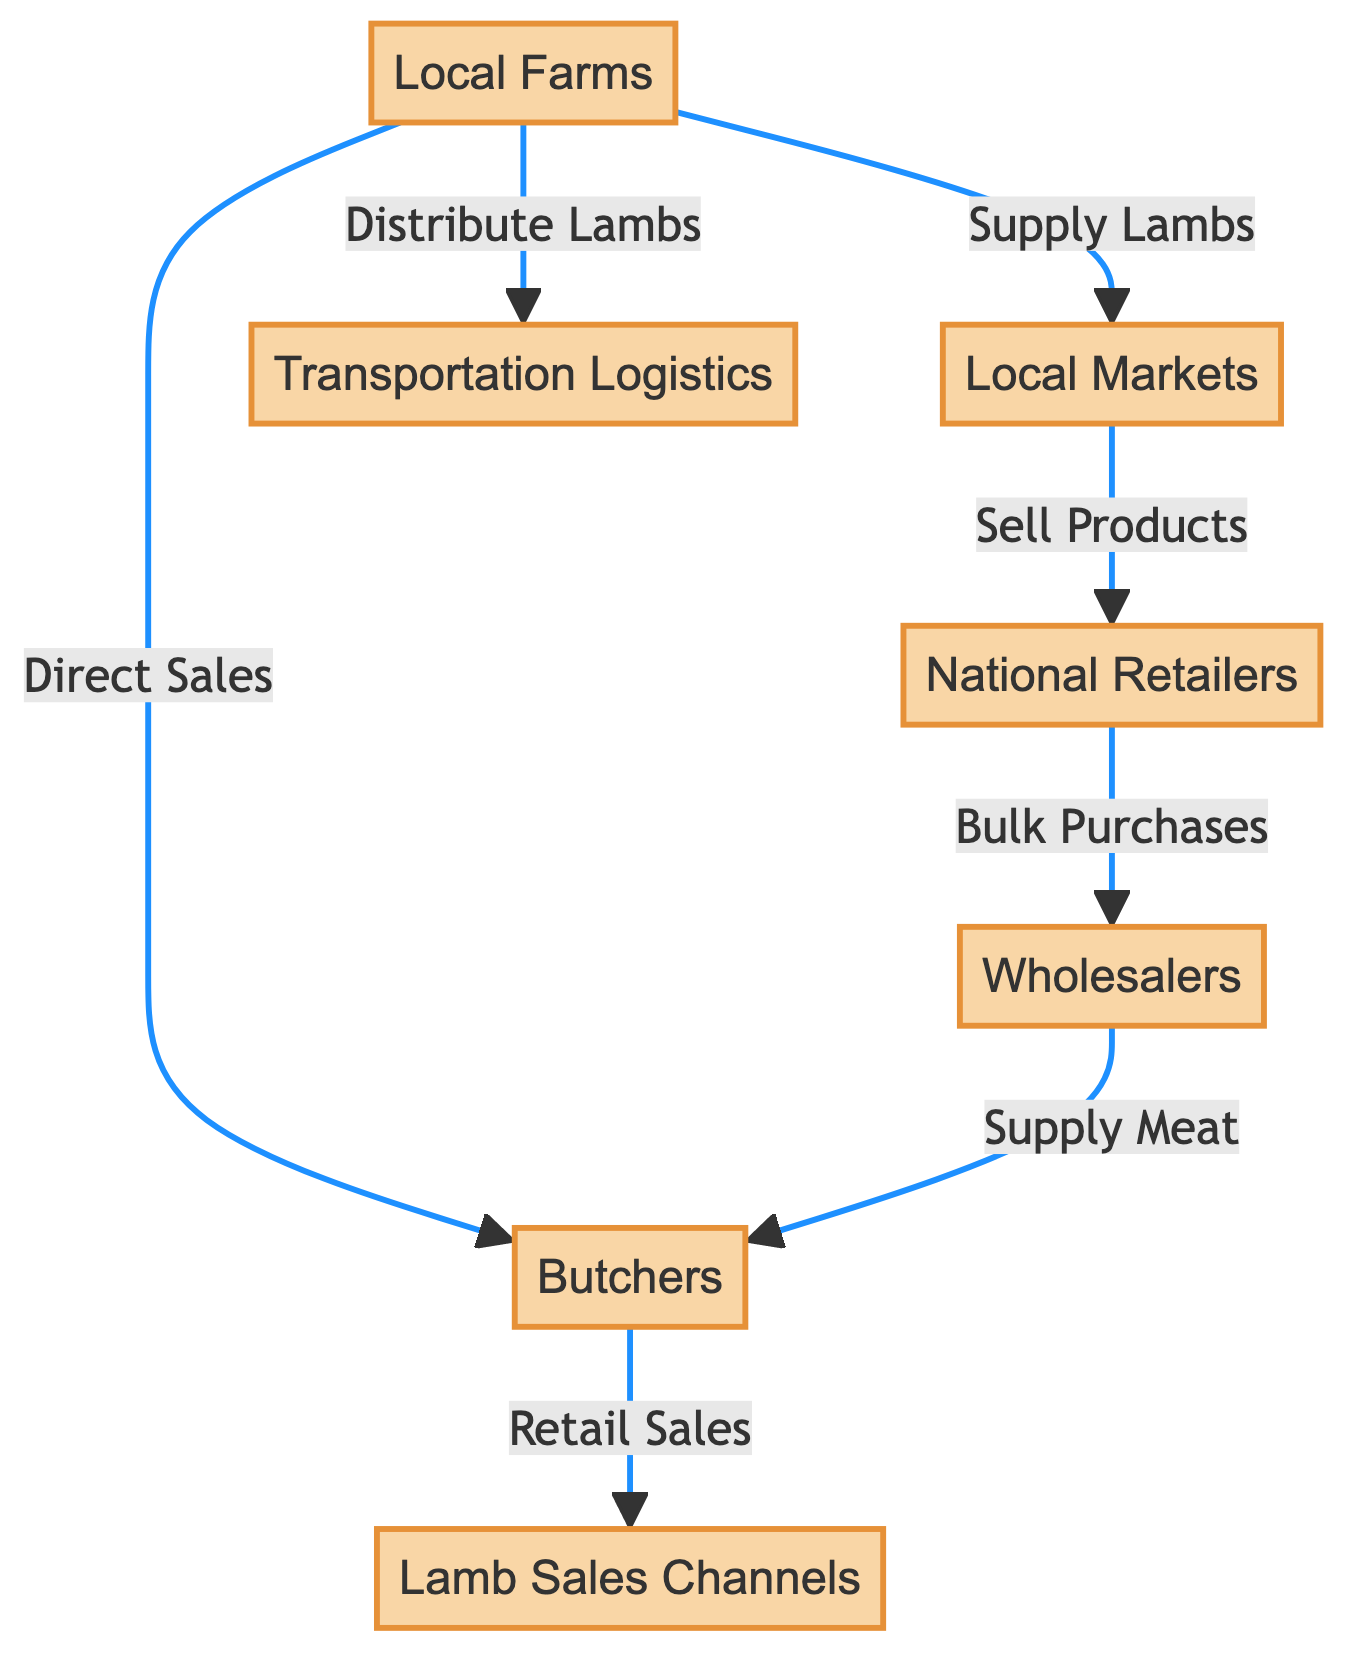What's the total number of nodes in the diagram? The diagram includes Local Farms, Local Markets, National Retailers, Wholesalers, Butchers, Transportation Logistics, and Lamb Sales Channels, making a total of seven nodes.
Answer: 7 Which node directly receives lambs from local farms? The Local Markets node directly receives lambs from the Local Farms node, as indicated by the edge labeled "Supply Lambs".
Answer: Local Markets How many edges connect Local Farms to other nodes? There are three edges stemming from Local Farms: to Local Markets (Supply Lambs), to Transportation Logistics (Distribute Lambs), and to Butchers (Direct Sales), totaling three connections.
Answer: 3 What is the relationship between National Retailers and Wholesalers? The edge labeled "Bulk Purchases" indicates that National Retailers purchase in bulk from Wholesalers, establishing a direct relationship between these two nodes.
Answer: Bulk Purchases Who provides meat to Butchers? The Wholesalers node supplies meat to Butchers, as shown by the edge labeled "Supply Meat".
Answer: Wholesalers Which node is the endpoint for retail sales in this network? The endpoint for retail sales is Lamb Sales Channels, which receives retail sales from Butchers through the edge labeled "Retail Sales".
Answer: Lamb Sales Channels What flows from Local Markets to National Retailers? Local Markets sell products to National Retailers, as indicated by the edge labeled "Sell Products".
Answer: Sell Products Which node is connected to Local Farms but not directly to National Retailers? Transportation Logistics is connected to Local Farms through the edge labeled "Distribute Lambs" but is not directly connected to National Retailers.
Answer: Transportation Logistics How many relationships involve Butchers in the diagram? Butchers are involved in two relationships: receiving Direct Sales from Local Farms and Supply Meat from Wholesalers.
Answer: 2 